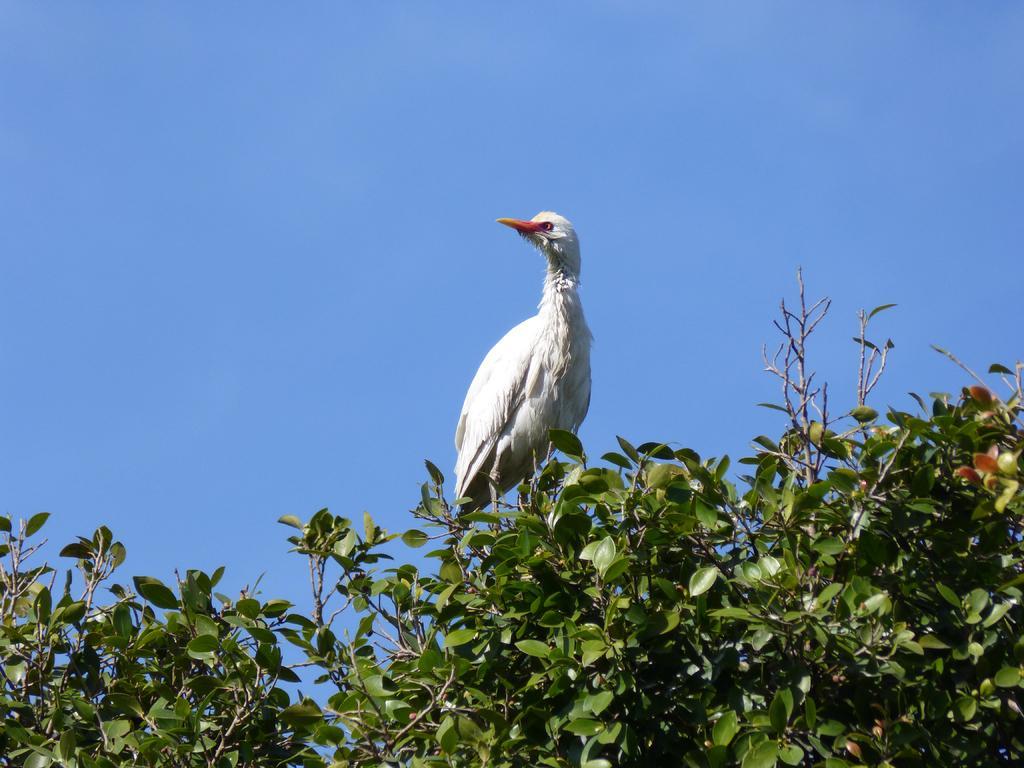Please provide a concise description of this image. This picture contains a white bird. This bird is on the tree. It has a long yellow colored beak. In the background, we see the sky, which is blue in color. 